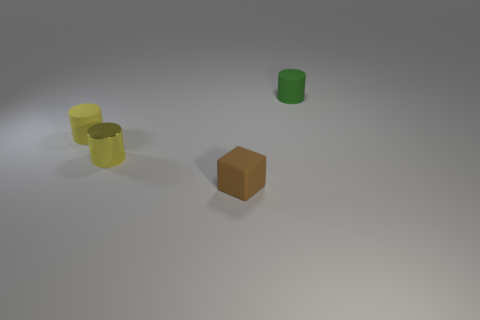What textures are evident on the surfaces of the objects? The objects seem to have fairly smooth surfaces with minimal textural detail. The metal object, in particular, has a slight reflection that implies a smooth metallic texture. Could you guess what material each object might be made of? Based on their appearances, the cylindrical objects could be made of plastic or painted metal due to their matte finish, while the cube reflects more light, suggesting it might be made of a polished metal or a similarly reflective material. 